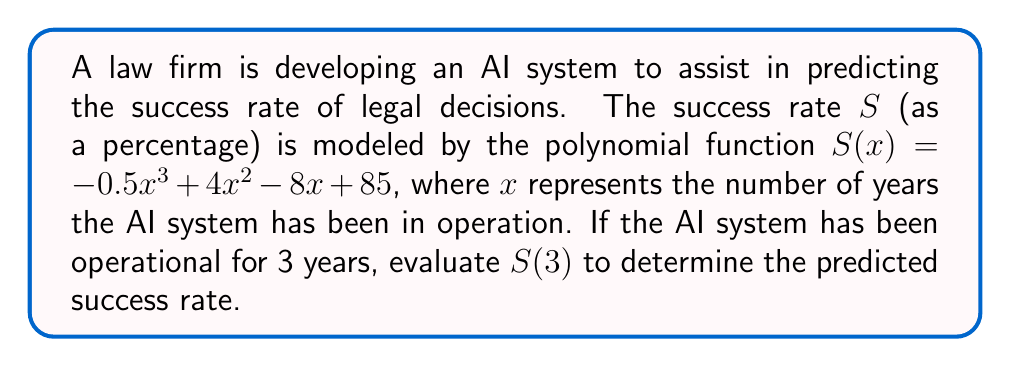Solve this math problem. To evaluate the polynomial expression $S(3)$, we need to substitute $x=3$ into the given function:

$S(x) = -0.5x^3 + 4x^2 - 8x + 85$

Step 1: Substitute $x=3$
$S(3) = -0.5(3)^3 + 4(3)^2 - 8(3) + 85$

Step 2: Evaluate the exponents
$S(3) = -0.5(27) + 4(9) - 8(3) + 85$

Step 3: Multiply
$S(3) = -13.5 + 36 - 24 + 85$

Step 4: Add and subtract from left to right
$S(3) = 22.5 + 85 = 107.5$

Therefore, the predicted success rate after 3 years of AI system operation is 107.5%.

Note: In reality, a success rate over 100% is not possible. This result suggests that the polynomial model may not be accurate for all input values and should be refined or limited to a specific domain to ensure realistic predictions.
Answer: 107.5% 